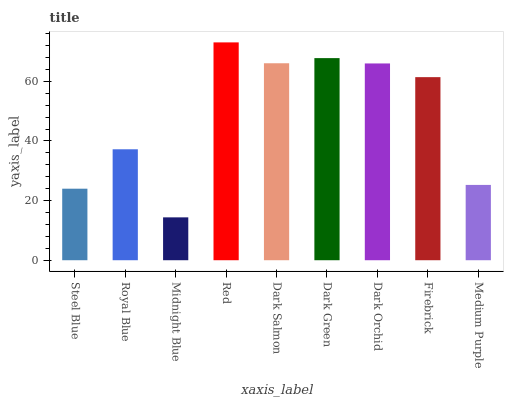Is Midnight Blue the minimum?
Answer yes or no. Yes. Is Red the maximum?
Answer yes or no. Yes. Is Royal Blue the minimum?
Answer yes or no. No. Is Royal Blue the maximum?
Answer yes or no. No. Is Royal Blue greater than Steel Blue?
Answer yes or no. Yes. Is Steel Blue less than Royal Blue?
Answer yes or no. Yes. Is Steel Blue greater than Royal Blue?
Answer yes or no. No. Is Royal Blue less than Steel Blue?
Answer yes or no. No. Is Firebrick the high median?
Answer yes or no. Yes. Is Firebrick the low median?
Answer yes or no. Yes. Is Dark Orchid the high median?
Answer yes or no. No. Is Midnight Blue the low median?
Answer yes or no. No. 